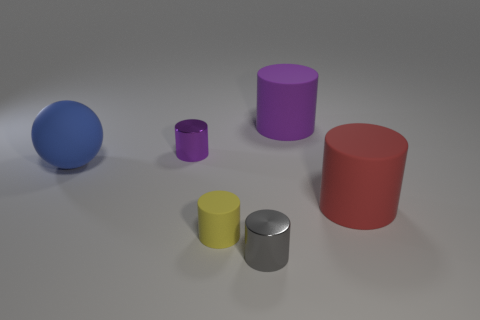Is the shape of the tiny object that is behind the yellow thing the same as the object on the right side of the big purple cylinder?
Give a very brief answer. Yes. What number of objects are either objects that are behind the purple metallic thing or matte objects to the right of the big blue sphere?
Give a very brief answer. 3. How many other things are there of the same material as the gray thing?
Make the answer very short. 1. Do the purple thing that is right of the yellow rubber cylinder and the big red object have the same material?
Give a very brief answer. Yes. Is the number of rubber cylinders that are behind the tiny gray object greater than the number of big purple cylinders right of the purple rubber cylinder?
Offer a terse response. Yes. How many objects are small gray shiny cylinders that are on the left side of the large red object or big purple matte things?
Ensure brevity in your answer.  2. What shape is the blue thing that is made of the same material as the big red object?
Provide a short and direct response. Sphere. Is there any other thing that is the same shape as the big blue object?
Ensure brevity in your answer.  No. What color is the tiny object that is both left of the gray metal cylinder and in front of the large blue matte ball?
Give a very brief answer. Yellow. What number of cylinders are either tiny yellow things or tiny objects?
Ensure brevity in your answer.  3. 